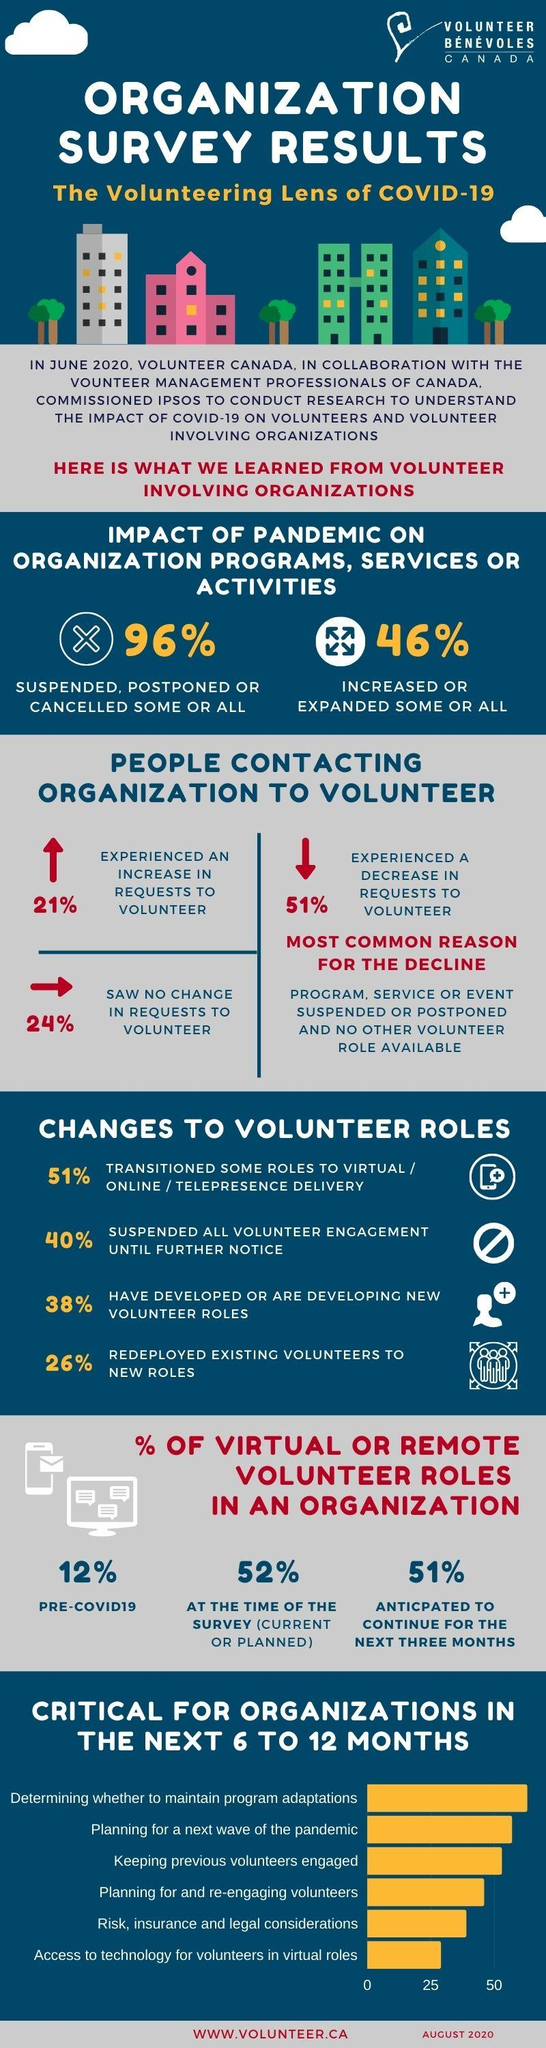Outline some significant characteristics in this image. There was a significant decrease of 51% in the number of requests to volunteer during the COVID-19 pandemic. During the pandemic, there was a significant increase in the number of requests for volunteer programs. Specifically, there was a 79% increase in the number of additional requests for volunteer programs compared to before the pandemic. According to the survey, 51% of volunteer organizations plan to continue their activities virtually for a few more months. According to the data, 26% of volunteer organizations have reassigned their workers to other positions. According to the survey conducted on volunteer organizations, 24% reported no difficulties in continuing their volunteering activities during the pandemic. 